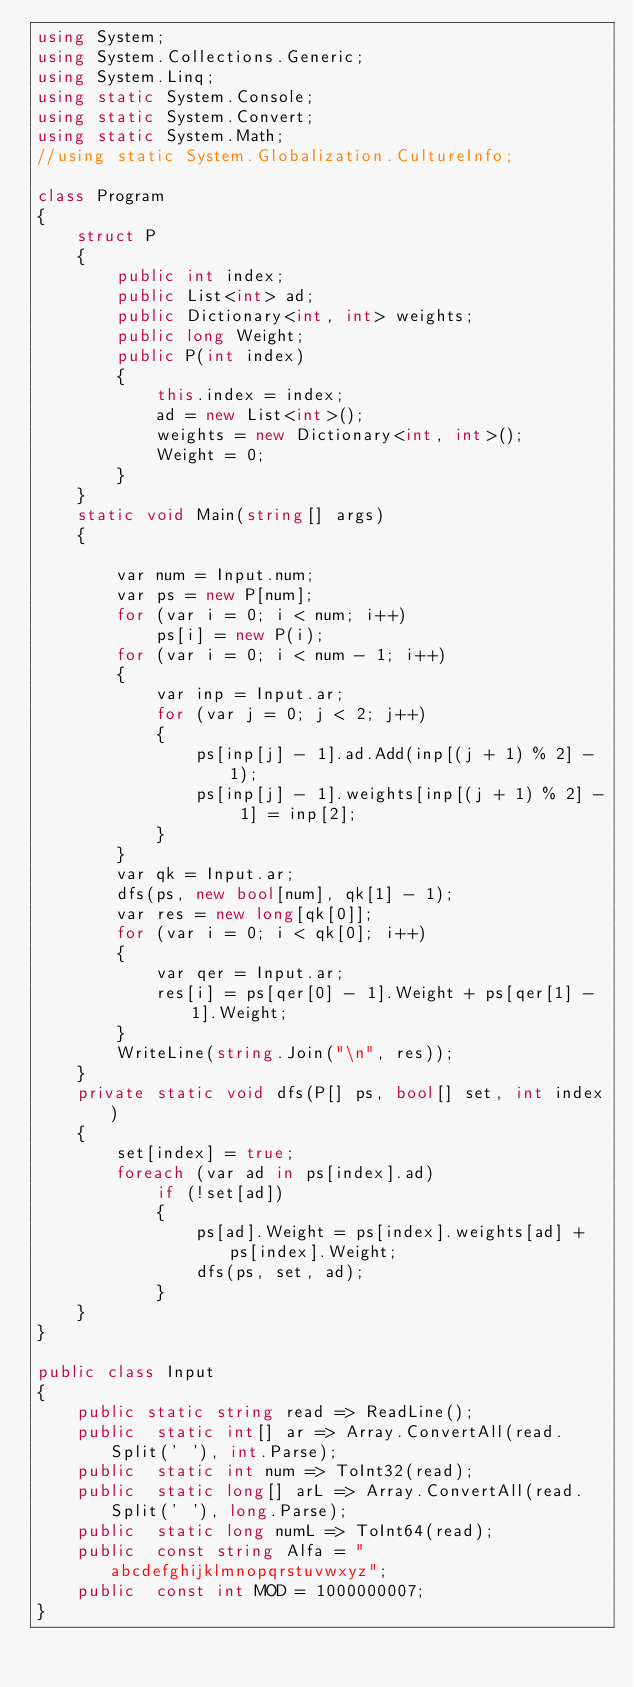<code> <loc_0><loc_0><loc_500><loc_500><_C#_>using System;
using System.Collections.Generic;
using System.Linq;
using static System.Console;
using static System.Convert;
using static System.Math;
//using static System.Globalization.CultureInfo;

class Program
{
    struct P
    {
        public int index;
        public List<int> ad;
        public Dictionary<int, int> weights;
        public long Weight;
        public P(int index)
        {
            this.index = index;
            ad = new List<int>();
            weights = new Dictionary<int, int>();
            Weight = 0;
        }
    }
    static void Main(string[] args)
    {

        var num = Input.num;
        var ps = new P[num];
        for (var i = 0; i < num; i++)
            ps[i] = new P(i);
        for (var i = 0; i < num - 1; i++)
        {
            var inp = Input.ar;
            for (var j = 0; j < 2; j++)
            {
                ps[inp[j] - 1].ad.Add(inp[(j + 1) % 2] - 1);
                ps[inp[j] - 1].weights[inp[(j + 1) % 2] - 1] = inp[2];
            }
        }
        var qk = Input.ar;
        dfs(ps, new bool[num], qk[1] - 1);
        var res = new long[qk[0]];
        for (var i = 0; i < qk[0]; i++)
        {
            var qer = Input.ar;
            res[i] = ps[qer[0] - 1].Weight + ps[qer[1] - 1].Weight;
        }
        WriteLine(string.Join("\n", res));
    }
    private static void dfs(P[] ps, bool[] set, int index)
    {
        set[index] = true;
        foreach (var ad in ps[index].ad)
            if (!set[ad])
            {
                ps[ad].Weight = ps[index].weights[ad] + ps[index].Weight;
                dfs(ps, set, ad);
            }
    }
}

public class Input
{
    public static string read => ReadLine();
    public  static int[] ar => Array.ConvertAll(read.Split(' '), int.Parse);
    public  static int num => ToInt32(read);
    public  static long[] arL => Array.ConvertAll(read.Split(' '), long.Parse);
    public  static long numL => ToInt64(read);
    public  const string Alfa = "abcdefghijklmnopqrstuvwxyz";
    public  const int MOD = 1000000007;
}
</code> 